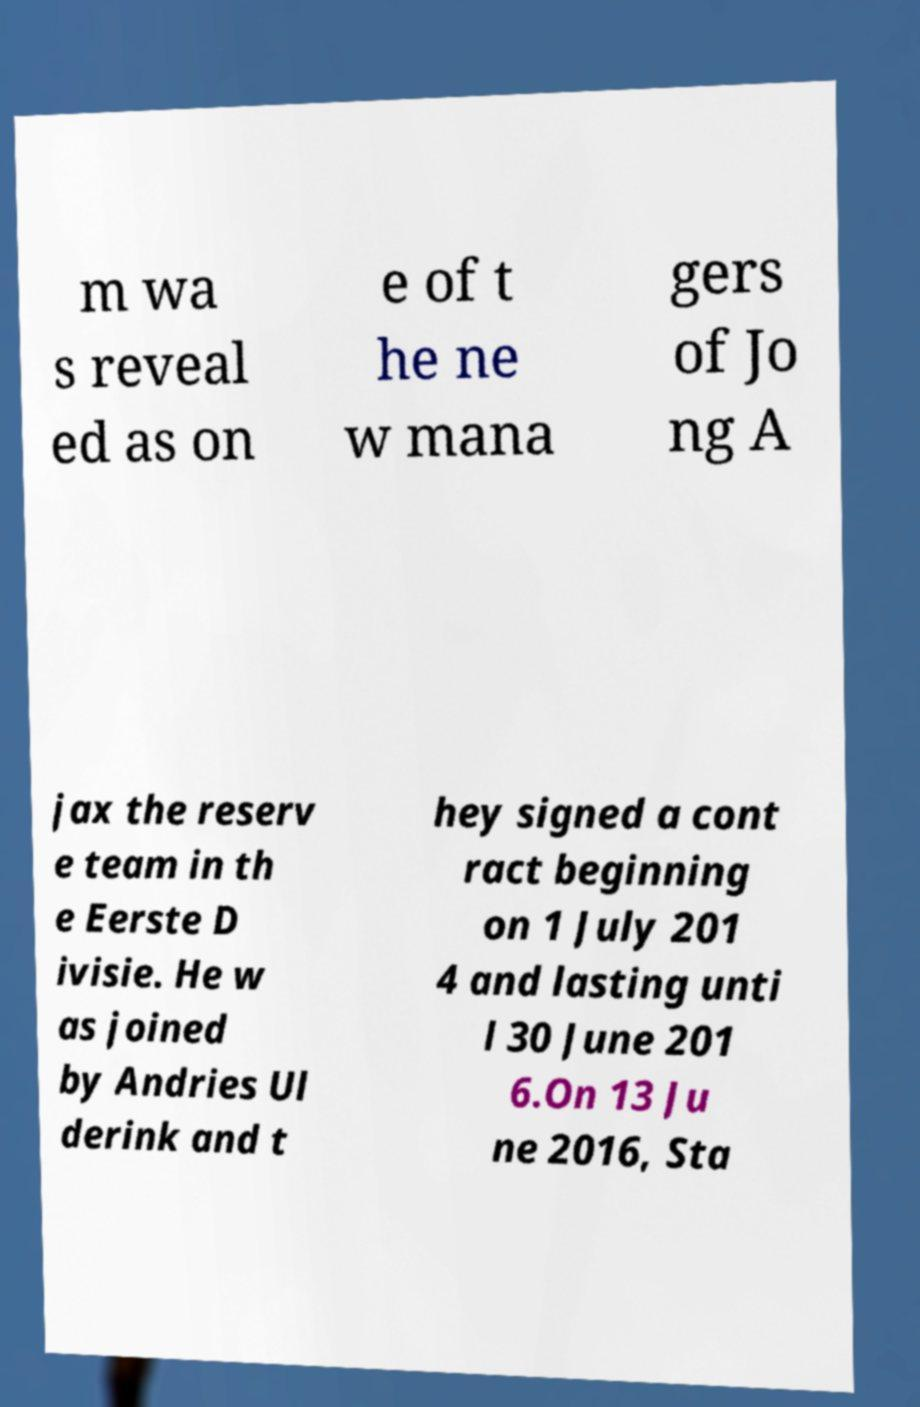Can you accurately transcribe the text from the provided image for me? m wa s reveal ed as on e of t he ne w mana gers of Jo ng A jax the reserv e team in th e Eerste D ivisie. He w as joined by Andries Ul derink and t hey signed a cont ract beginning on 1 July 201 4 and lasting unti l 30 June 201 6.On 13 Ju ne 2016, Sta 